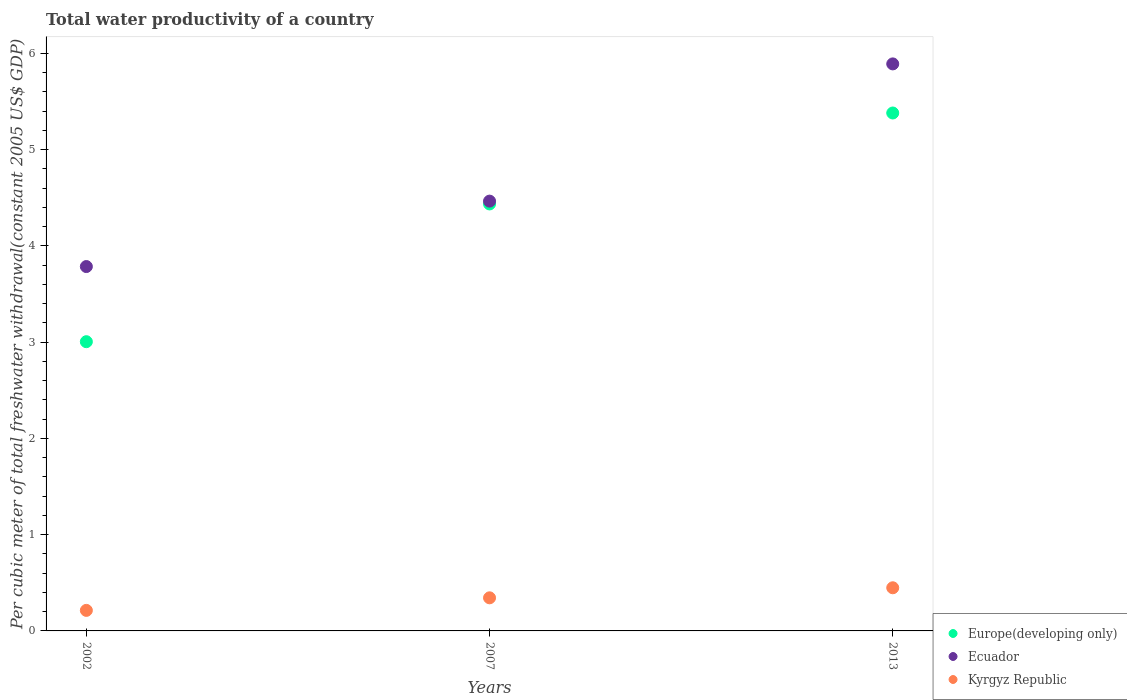What is the total water productivity in Europe(developing only) in 2002?
Your answer should be very brief. 3. Across all years, what is the maximum total water productivity in Europe(developing only)?
Your response must be concise. 5.38. Across all years, what is the minimum total water productivity in Europe(developing only)?
Your answer should be compact. 3. In which year was the total water productivity in Kyrgyz Republic minimum?
Your answer should be compact. 2002. What is the total total water productivity in Europe(developing only) in the graph?
Make the answer very short. 12.82. What is the difference between the total water productivity in Ecuador in 2007 and that in 2013?
Offer a very short reply. -1.43. What is the difference between the total water productivity in Ecuador in 2002 and the total water productivity in Europe(developing only) in 2013?
Your answer should be very brief. -1.6. What is the average total water productivity in Kyrgyz Republic per year?
Provide a short and direct response. 0.34. In the year 2002, what is the difference between the total water productivity in Europe(developing only) and total water productivity in Kyrgyz Republic?
Your answer should be very brief. 2.79. In how many years, is the total water productivity in Ecuador greater than 2 US$?
Keep it short and to the point. 3. What is the ratio of the total water productivity in Europe(developing only) in 2007 to that in 2013?
Provide a succinct answer. 0.82. Is the difference between the total water productivity in Europe(developing only) in 2002 and 2007 greater than the difference between the total water productivity in Kyrgyz Republic in 2002 and 2007?
Provide a succinct answer. No. What is the difference between the highest and the second highest total water productivity in Europe(developing only)?
Your response must be concise. 0.94. What is the difference between the highest and the lowest total water productivity in Europe(developing only)?
Your answer should be very brief. 2.38. Is it the case that in every year, the sum of the total water productivity in Ecuador and total water productivity in Europe(developing only)  is greater than the total water productivity in Kyrgyz Republic?
Your response must be concise. Yes. Is the total water productivity in Kyrgyz Republic strictly greater than the total water productivity in Ecuador over the years?
Keep it short and to the point. No. Are the values on the major ticks of Y-axis written in scientific E-notation?
Your answer should be very brief. No. Does the graph contain any zero values?
Give a very brief answer. No. How many legend labels are there?
Provide a short and direct response. 3. What is the title of the graph?
Provide a short and direct response. Total water productivity of a country. Does "French Polynesia" appear as one of the legend labels in the graph?
Provide a succinct answer. No. What is the label or title of the X-axis?
Offer a terse response. Years. What is the label or title of the Y-axis?
Make the answer very short. Per cubic meter of total freshwater withdrawal(constant 2005 US$ GDP). What is the Per cubic meter of total freshwater withdrawal(constant 2005 US$ GDP) of Europe(developing only) in 2002?
Keep it short and to the point. 3. What is the Per cubic meter of total freshwater withdrawal(constant 2005 US$ GDP) in Ecuador in 2002?
Give a very brief answer. 3.79. What is the Per cubic meter of total freshwater withdrawal(constant 2005 US$ GDP) in Kyrgyz Republic in 2002?
Your response must be concise. 0.21. What is the Per cubic meter of total freshwater withdrawal(constant 2005 US$ GDP) in Europe(developing only) in 2007?
Offer a very short reply. 4.44. What is the Per cubic meter of total freshwater withdrawal(constant 2005 US$ GDP) in Ecuador in 2007?
Offer a very short reply. 4.47. What is the Per cubic meter of total freshwater withdrawal(constant 2005 US$ GDP) of Kyrgyz Republic in 2007?
Offer a very short reply. 0.34. What is the Per cubic meter of total freshwater withdrawal(constant 2005 US$ GDP) in Europe(developing only) in 2013?
Provide a succinct answer. 5.38. What is the Per cubic meter of total freshwater withdrawal(constant 2005 US$ GDP) in Ecuador in 2013?
Provide a short and direct response. 5.89. What is the Per cubic meter of total freshwater withdrawal(constant 2005 US$ GDP) of Kyrgyz Republic in 2013?
Your response must be concise. 0.45. Across all years, what is the maximum Per cubic meter of total freshwater withdrawal(constant 2005 US$ GDP) of Europe(developing only)?
Provide a succinct answer. 5.38. Across all years, what is the maximum Per cubic meter of total freshwater withdrawal(constant 2005 US$ GDP) of Ecuador?
Offer a terse response. 5.89. Across all years, what is the maximum Per cubic meter of total freshwater withdrawal(constant 2005 US$ GDP) of Kyrgyz Republic?
Make the answer very short. 0.45. Across all years, what is the minimum Per cubic meter of total freshwater withdrawal(constant 2005 US$ GDP) of Europe(developing only)?
Your response must be concise. 3. Across all years, what is the minimum Per cubic meter of total freshwater withdrawal(constant 2005 US$ GDP) of Ecuador?
Make the answer very short. 3.79. Across all years, what is the minimum Per cubic meter of total freshwater withdrawal(constant 2005 US$ GDP) of Kyrgyz Republic?
Your answer should be very brief. 0.21. What is the total Per cubic meter of total freshwater withdrawal(constant 2005 US$ GDP) of Europe(developing only) in the graph?
Provide a short and direct response. 12.82. What is the total Per cubic meter of total freshwater withdrawal(constant 2005 US$ GDP) in Ecuador in the graph?
Offer a terse response. 14.14. What is the total Per cubic meter of total freshwater withdrawal(constant 2005 US$ GDP) in Kyrgyz Republic in the graph?
Offer a terse response. 1.01. What is the difference between the Per cubic meter of total freshwater withdrawal(constant 2005 US$ GDP) in Europe(developing only) in 2002 and that in 2007?
Provide a short and direct response. -1.43. What is the difference between the Per cubic meter of total freshwater withdrawal(constant 2005 US$ GDP) in Ecuador in 2002 and that in 2007?
Your answer should be very brief. -0.68. What is the difference between the Per cubic meter of total freshwater withdrawal(constant 2005 US$ GDP) in Kyrgyz Republic in 2002 and that in 2007?
Make the answer very short. -0.13. What is the difference between the Per cubic meter of total freshwater withdrawal(constant 2005 US$ GDP) of Europe(developing only) in 2002 and that in 2013?
Provide a short and direct response. -2.38. What is the difference between the Per cubic meter of total freshwater withdrawal(constant 2005 US$ GDP) in Ecuador in 2002 and that in 2013?
Provide a short and direct response. -2.11. What is the difference between the Per cubic meter of total freshwater withdrawal(constant 2005 US$ GDP) in Kyrgyz Republic in 2002 and that in 2013?
Offer a terse response. -0.23. What is the difference between the Per cubic meter of total freshwater withdrawal(constant 2005 US$ GDP) of Europe(developing only) in 2007 and that in 2013?
Make the answer very short. -0.94. What is the difference between the Per cubic meter of total freshwater withdrawal(constant 2005 US$ GDP) in Ecuador in 2007 and that in 2013?
Your answer should be compact. -1.43. What is the difference between the Per cubic meter of total freshwater withdrawal(constant 2005 US$ GDP) of Kyrgyz Republic in 2007 and that in 2013?
Provide a short and direct response. -0.1. What is the difference between the Per cubic meter of total freshwater withdrawal(constant 2005 US$ GDP) in Europe(developing only) in 2002 and the Per cubic meter of total freshwater withdrawal(constant 2005 US$ GDP) in Ecuador in 2007?
Your response must be concise. -1.46. What is the difference between the Per cubic meter of total freshwater withdrawal(constant 2005 US$ GDP) in Europe(developing only) in 2002 and the Per cubic meter of total freshwater withdrawal(constant 2005 US$ GDP) in Kyrgyz Republic in 2007?
Keep it short and to the point. 2.66. What is the difference between the Per cubic meter of total freshwater withdrawal(constant 2005 US$ GDP) of Ecuador in 2002 and the Per cubic meter of total freshwater withdrawal(constant 2005 US$ GDP) of Kyrgyz Republic in 2007?
Ensure brevity in your answer.  3.44. What is the difference between the Per cubic meter of total freshwater withdrawal(constant 2005 US$ GDP) of Europe(developing only) in 2002 and the Per cubic meter of total freshwater withdrawal(constant 2005 US$ GDP) of Ecuador in 2013?
Provide a succinct answer. -2.89. What is the difference between the Per cubic meter of total freshwater withdrawal(constant 2005 US$ GDP) in Europe(developing only) in 2002 and the Per cubic meter of total freshwater withdrawal(constant 2005 US$ GDP) in Kyrgyz Republic in 2013?
Your answer should be very brief. 2.56. What is the difference between the Per cubic meter of total freshwater withdrawal(constant 2005 US$ GDP) in Ecuador in 2002 and the Per cubic meter of total freshwater withdrawal(constant 2005 US$ GDP) in Kyrgyz Republic in 2013?
Keep it short and to the point. 3.34. What is the difference between the Per cubic meter of total freshwater withdrawal(constant 2005 US$ GDP) in Europe(developing only) in 2007 and the Per cubic meter of total freshwater withdrawal(constant 2005 US$ GDP) in Ecuador in 2013?
Make the answer very short. -1.45. What is the difference between the Per cubic meter of total freshwater withdrawal(constant 2005 US$ GDP) in Europe(developing only) in 2007 and the Per cubic meter of total freshwater withdrawal(constant 2005 US$ GDP) in Kyrgyz Republic in 2013?
Make the answer very short. 3.99. What is the difference between the Per cubic meter of total freshwater withdrawal(constant 2005 US$ GDP) in Ecuador in 2007 and the Per cubic meter of total freshwater withdrawal(constant 2005 US$ GDP) in Kyrgyz Republic in 2013?
Provide a succinct answer. 4.02. What is the average Per cubic meter of total freshwater withdrawal(constant 2005 US$ GDP) in Europe(developing only) per year?
Provide a short and direct response. 4.27. What is the average Per cubic meter of total freshwater withdrawal(constant 2005 US$ GDP) of Ecuador per year?
Your response must be concise. 4.71. What is the average Per cubic meter of total freshwater withdrawal(constant 2005 US$ GDP) in Kyrgyz Republic per year?
Provide a short and direct response. 0.34. In the year 2002, what is the difference between the Per cubic meter of total freshwater withdrawal(constant 2005 US$ GDP) of Europe(developing only) and Per cubic meter of total freshwater withdrawal(constant 2005 US$ GDP) of Ecuador?
Offer a terse response. -0.78. In the year 2002, what is the difference between the Per cubic meter of total freshwater withdrawal(constant 2005 US$ GDP) of Europe(developing only) and Per cubic meter of total freshwater withdrawal(constant 2005 US$ GDP) of Kyrgyz Republic?
Offer a terse response. 2.79. In the year 2002, what is the difference between the Per cubic meter of total freshwater withdrawal(constant 2005 US$ GDP) in Ecuador and Per cubic meter of total freshwater withdrawal(constant 2005 US$ GDP) in Kyrgyz Republic?
Offer a very short reply. 3.57. In the year 2007, what is the difference between the Per cubic meter of total freshwater withdrawal(constant 2005 US$ GDP) of Europe(developing only) and Per cubic meter of total freshwater withdrawal(constant 2005 US$ GDP) of Ecuador?
Make the answer very short. -0.03. In the year 2007, what is the difference between the Per cubic meter of total freshwater withdrawal(constant 2005 US$ GDP) of Europe(developing only) and Per cubic meter of total freshwater withdrawal(constant 2005 US$ GDP) of Kyrgyz Republic?
Make the answer very short. 4.09. In the year 2007, what is the difference between the Per cubic meter of total freshwater withdrawal(constant 2005 US$ GDP) in Ecuador and Per cubic meter of total freshwater withdrawal(constant 2005 US$ GDP) in Kyrgyz Republic?
Your answer should be compact. 4.12. In the year 2013, what is the difference between the Per cubic meter of total freshwater withdrawal(constant 2005 US$ GDP) of Europe(developing only) and Per cubic meter of total freshwater withdrawal(constant 2005 US$ GDP) of Ecuador?
Your answer should be very brief. -0.51. In the year 2013, what is the difference between the Per cubic meter of total freshwater withdrawal(constant 2005 US$ GDP) of Europe(developing only) and Per cubic meter of total freshwater withdrawal(constant 2005 US$ GDP) of Kyrgyz Republic?
Keep it short and to the point. 4.93. In the year 2013, what is the difference between the Per cubic meter of total freshwater withdrawal(constant 2005 US$ GDP) in Ecuador and Per cubic meter of total freshwater withdrawal(constant 2005 US$ GDP) in Kyrgyz Republic?
Ensure brevity in your answer.  5.44. What is the ratio of the Per cubic meter of total freshwater withdrawal(constant 2005 US$ GDP) of Europe(developing only) in 2002 to that in 2007?
Your answer should be very brief. 0.68. What is the ratio of the Per cubic meter of total freshwater withdrawal(constant 2005 US$ GDP) of Ecuador in 2002 to that in 2007?
Keep it short and to the point. 0.85. What is the ratio of the Per cubic meter of total freshwater withdrawal(constant 2005 US$ GDP) of Kyrgyz Republic in 2002 to that in 2007?
Keep it short and to the point. 0.62. What is the ratio of the Per cubic meter of total freshwater withdrawal(constant 2005 US$ GDP) of Europe(developing only) in 2002 to that in 2013?
Your response must be concise. 0.56. What is the ratio of the Per cubic meter of total freshwater withdrawal(constant 2005 US$ GDP) of Ecuador in 2002 to that in 2013?
Offer a very short reply. 0.64. What is the ratio of the Per cubic meter of total freshwater withdrawal(constant 2005 US$ GDP) in Kyrgyz Republic in 2002 to that in 2013?
Give a very brief answer. 0.48. What is the ratio of the Per cubic meter of total freshwater withdrawal(constant 2005 US$ GDP) of Europe(developing only) in 2007 to that in 2013?
Your response must be concise. 0.82. What is the ratio of the Per cubic meter of total freshwater withdrawal(constant 2005 US$ GDP) in Ecuador in 2007 to that in 2013?
Your response must be concise. 0.76. What is the ratio of the Per cubic meter of total freshwater withdrawal(constant 2005 US$ GDP) in Kyrgyz Republic in 2007 to that in 2013?
Your answer should be very brief. 0.77. What is the difference between the highest and the second highest Per cubic meter of total freshwater withdrawal(constant 2005 US$ GDP) in Europe(developing only)?
Your answer should be very brief. 0.94. What is the difference between the highest and the second highest Per cubic meter of total freshwater withdrawal(constant 2005 US$ GDP) of Ecuador?
Ensure brevity in your answer.  1.43. What is the difference between the highest and the second highest Per cubic meter of total freshwater withdrawal(constant 2005 US$ GDP) of Kyrgyz Republic?
Give a very brief answer. 0.1. What is the difference between the highest and the lowest Per cubic meter of total freshwater withdrawal(constant 2005 US$ GDP) of Europe(developing only)?
Ensure brevity in your answer.  2.38. What is the difference between the highest and the lowest Per cubic meter of total freshwater withdrawal(constant 2005 US$ GDP) of Ecuador?
Ensure brevity in your answer.  2.11. What is the difference between the highest and the lowest Per cubic meter of total freshwater withdrawal(constant 2005 US$ GDP) of Kyrgyz Republic?
Your answer should be compact. 0.23. 